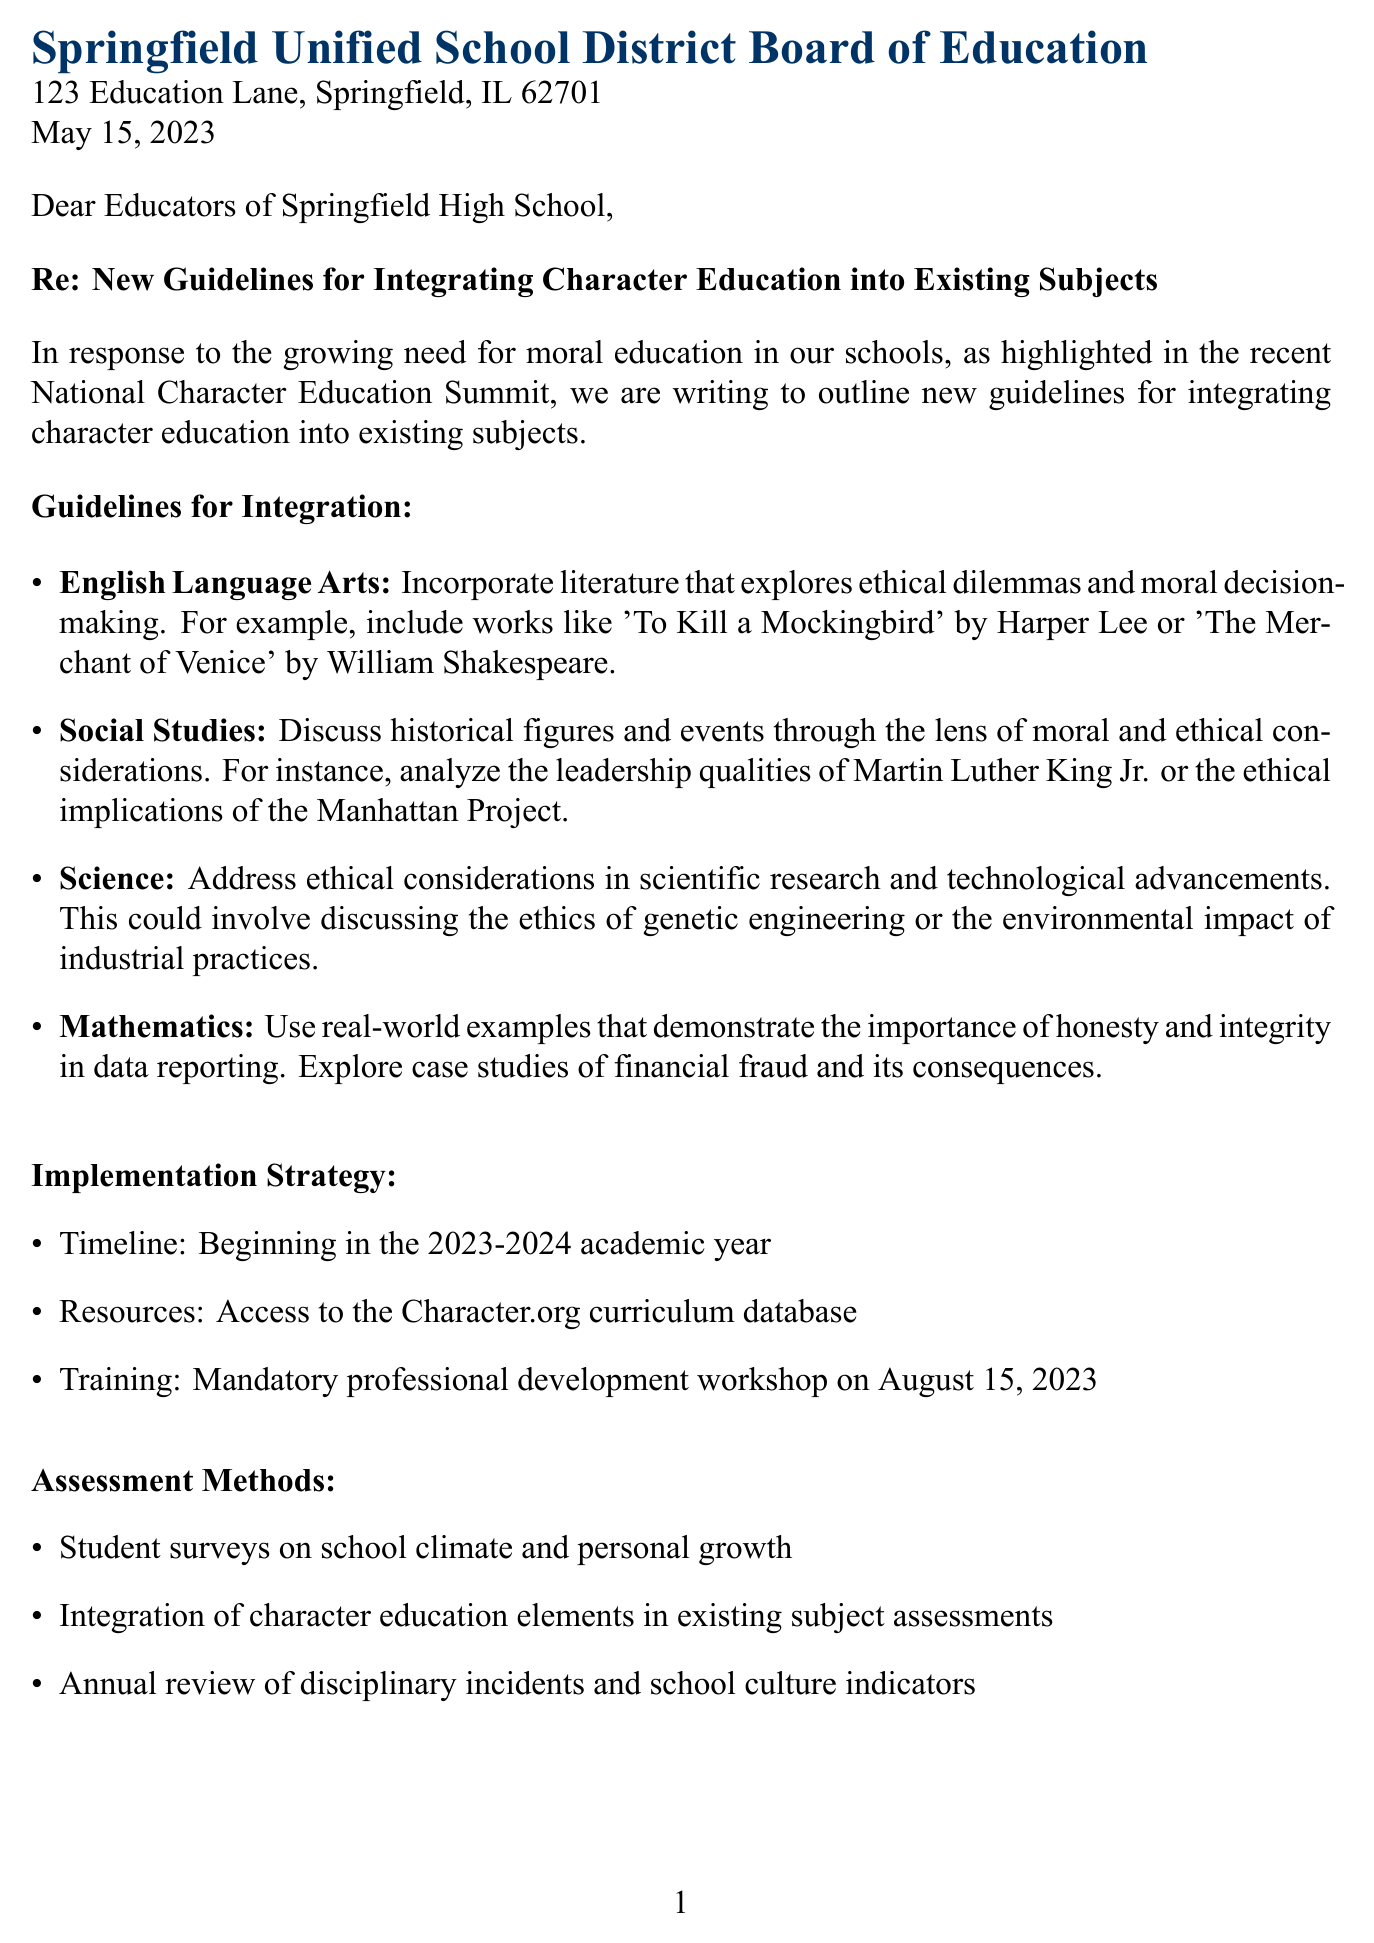What is the date of the letter? The date is specified in the document header, representing the official writing date of the letter.
Answer: May 15, 2023 Who is the sender of the letter? The sender is identified at the end of the document, indicating the authority behind the communication.
Answer: Dr. Emily Hawkins What subject area includes discussions on Martin Luther King Jr.? The subject area is indicated as part of the guidelines in the document covering ethical considerations and historical analysis.
Answer: Social Studies When will the implementation of the guidelines begin? The timeline for implementation is clearly stated in the document, indicating when educators should start applying the new guidelines.
Answer: 2023-2024 academic year What type of workshop is mandatory for educators? The document specifies the nature of the training that educators must attend to help with implementation.
Answer: Professional development workshop Which organization will provide resources for the new curriculum? The document mentions a specific organization that will offer resources to educators for character education.
Answer: Character.org How will the effectiveness of character education be assessed? The document outlines methods for assessing the integration of character education in schools, reflecting on how the impact will be measured.
Answer: Student surveys What literary work is suggested for English Language Arts integration? The document provides examples of literature that align with the new character education guidelines for this subject area.
Answer: To Kill a Mockingbird What is one example of ethical consideration in science discussed in the letter? The letter specifies topics related to ethics in science that should be addressed in education.
Answer: Genetic engineering 